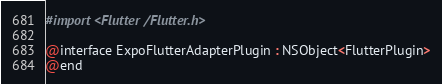<code> <loc_0><loc_0><loc_500><loc_500><_C_>#import <Flutter/Flutter.h>

@interface ExpoFlutterAdapterPlugin : NSObject<FlutterPlugin>
@end
</code> 